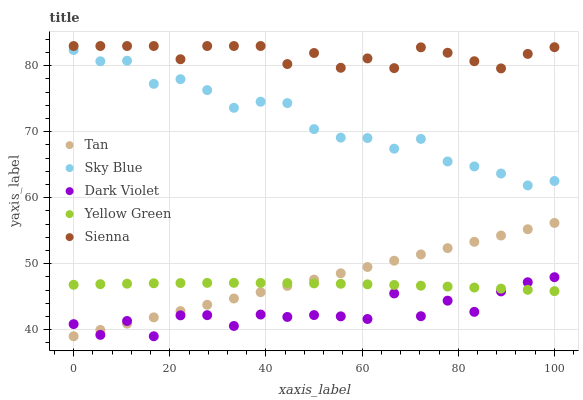Does Dark Violet have the minimum area under the curve?
Answer yes or no. Yes. Does Sienna have the maximum area under the curve?
Answer yes or no. Yes. Does Sky Blue have the minimum area under the curve?
Answer yes or no. No. Does Sky Blue have the maximum area under the curve?
Answer yes or no. No. Is Tan the smoothest?
Answer yes or no. Yes. Is Dark Violet the roughest?
Answer yes or no. Yes. Is Sky Blue the smoothest?
Answer yes or no. No. Is Sky Blue the roughest?
Answer yes or no. No. Does Tan have the lowest value?
Answer yes or no. Yes. Does Sky Blue have the lowest value?
Answer yes or no. No. Does Sienna have the highest value?
Answer yes or no. Yes. Does Sky Blue have the highest value?
Answer yes or no. No. Is Yellow Green less than Sky Blue?
Answer yes or no. Yes. Is Sky Blue greater than Yellow Green?
Answer yes or no. Yes. Does Dark Violet intersect Yellow Green?
Answer yes or no. Yes. Is Dark Violet less than Yellow Green?
Answer yes or no. No. Is Dark Violet greater than Yellow Green?
Answer yes or no. No. Does Yellow Green intersect Sky Blue?
Answer yes or no. No. 